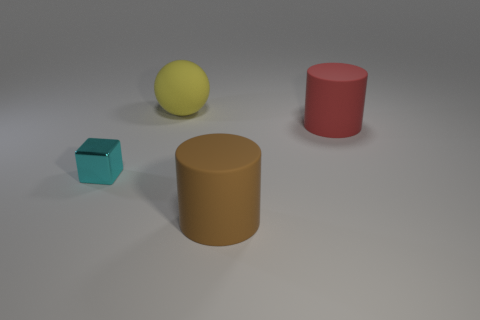There is a big matte object that is to the right of the brown rubber object; is it the same shape as the large thing that is in front of the red cylinder? Yes, the big matte object to the right of the brown cylindrical object shares the same spherical shape as the larger object positioned in front of the red cylinder. This discernment takes into account the shape characteristics observable from the given perspective in the image. 